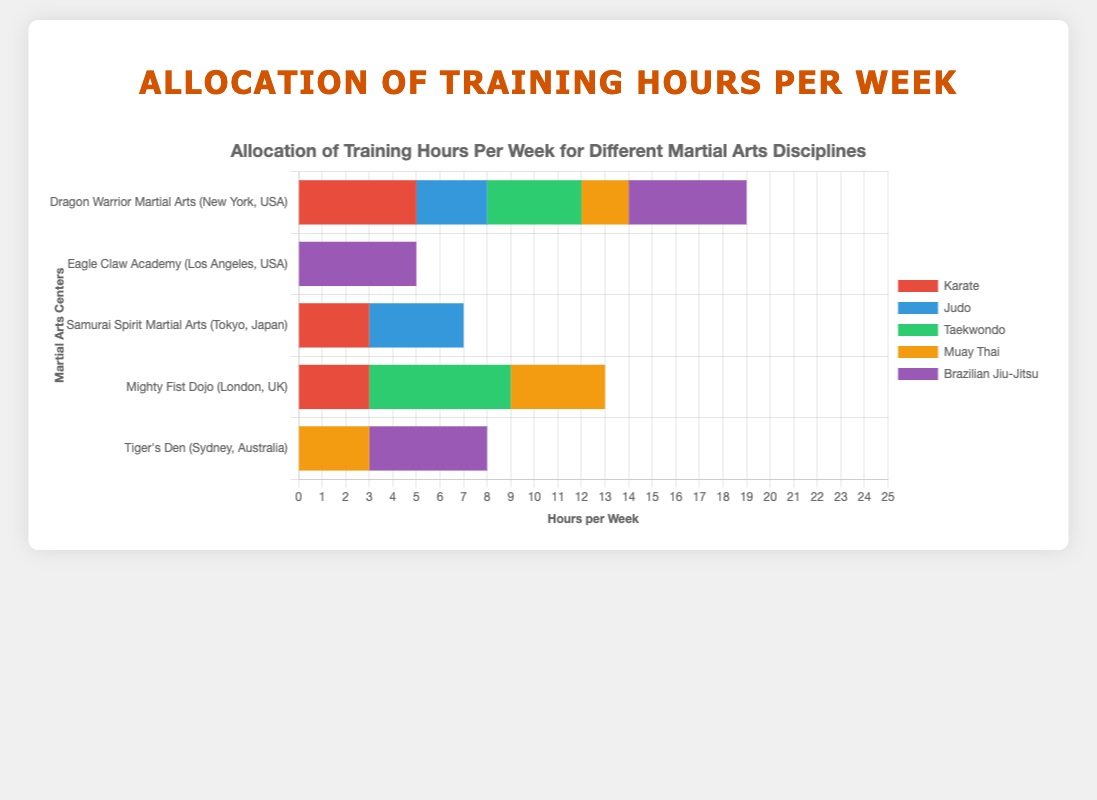Which center offers the most hours for Brazilian Jiu-Jitsu combined? To find this, sum the hours for Brazilian Jiu-Jitsu from each center. Dragon Warrior Martial Arts offers 5, Eagle Claw Academy offers 5, Samurai Spirit Martial Arts offers 0, Mighty Fist Dojo offers 0, and Tiger's Den offers 5. The total is 5 + 5 + 0 + 0 + 5 = 15 hours.
Answer: 15 hours Which martial art has the highest average training hours across all centers? Calculate the average by summing the hours for each discipline across all centers and then dividing by the number of centers. For example, Karate: (5 + 0 + 3 + 3 + 0) / 5 = 2.2; Continue for all disciplines: Judo (1.4), Taekwondo (2), Muay Thai (1.8), Brazilian Jiu-Jitsu (3), Kung Fu (1.2), Kickboxing (1.6), Aikido (1.4), Boxing (0.8), Ninjutsu (0.8), Kendo (1), Hapkido (0.6), Capoeira (0.8), Systema (0.4), Krav Maga (0.6). Brazilian Jiu-Jitsu has the highest average of 3 hours.
Answer: Brazilian Jiu-Jitsu Which center allocates the most hours in total for all disciplines combined? Sum the total hours for all disciplines for each center. Dragon Warrior Martial Arts (19 hours), Eagle Claw Academy (20 hours), Samurai Spirit Martial Arts (20 hours), Mighty Fist Dojo (21 hours), Tiger's Den (17 hours). Mighty Fist Dojo allocates the most hours.
Answer: Mighty Fist Dojo What is the shortest total training hours for any center? Sum the hours for all disciplines for each center and identify the center with the lowest sum. Dragon Warrior Martial Arts (19 hours), Eagle Claw Academy (20 hours), Samurai Spirit Martial Arts (20 hours), Mighty Fist Dojo (21 hours), Tiger's Den (17 hours). The lowest is Tiger's Den with 17 hours.
Answer: 17 hours How many hours are dedicated to martial arts (Judo + Karate) at Samurai Spirit Martial Arts? Add the hours for Judo and Karate at Samurai Spirit Martial Arts. Judo (4) + Karate (3) = 7 hours.
Answer: 7 hours Which martial art at Mighty Fist Dojo has the highest training hours? Look at the individual hours for each martial art at Mighty Fist Dojo: Taekwondo (6), Hapkido (3), Kickboxing (5), Muay Thai (4), Karate (3). The highest is Taekwondo with 6 hours.
Answer: Taekwondo Between Dragon Warrior Martial Arts and Eagle Claw Academy, which offers more total hours for Brazilian Jiu-Jitsu and Boxing combined? Sum the hours for both Brazilian Jiu-Jitsu and Boxing at each center and compare. Dragon Warrior Martial Arts: Brazilian Jiu-Jitsu (5) + Boxing (0) = 5 hours; Eagle Claw Academy: Brazilian Jiu-Jitsu (5) + Boxing (4) = 9 hours. Eagle Claw Academy offers more combined hours.
Answer: Eagle Claw Academy Which martial art is not offered at any center? Check the disciplines listed and ensure each discipline appears at least once across all centers. All listed martial arts are offered at least once, so none is entirely omitted.
Answer: None What is the difference in total training hours between Dragon Warrior Martial Arts and Mighty Fist Dojo? Sum the total hours at Dragon Warrior Martial Arts (19 hours) and Mighty Fist Dojo (21 hours), then calculate the difference. 21 - 19 = 2 hours.
Answer: 2 hours 